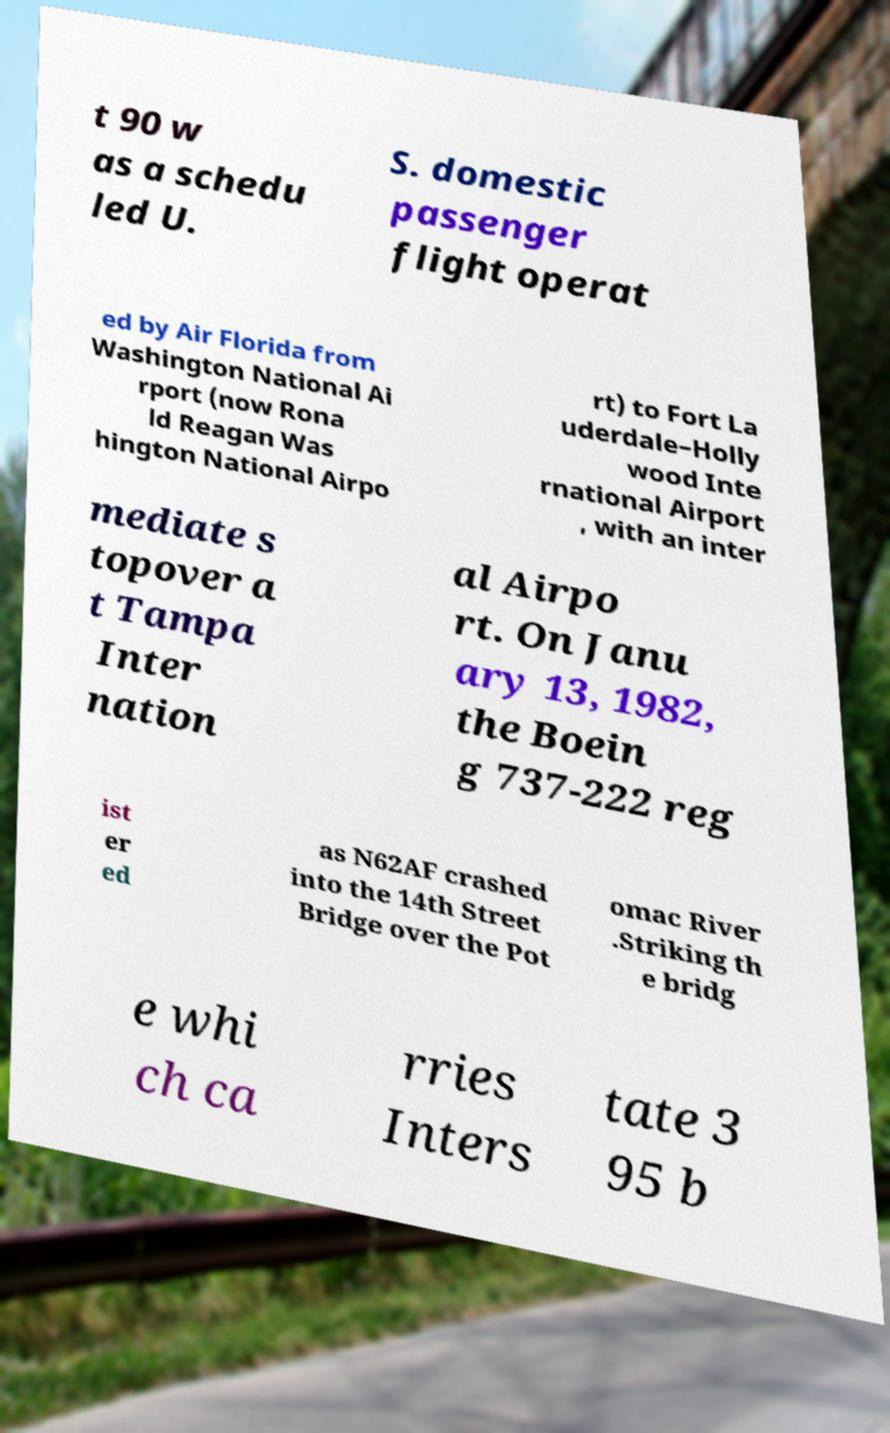Could you assist in decoding the text presented in this image and type it out clearly? t 90 w as a schedu led U. S. domestic passenger flight operat ed by Air Florida from Washington National Ai rport (now Rona ld Reagan Was hington National Airpo rt) to Fort La uderdale–Holly wood Inte rnational Airport , with an inter mediate s topover a t Tampa Inter nation al Airpo rt. On Janu ary 13, 1982, the Boein g 737-222 reg ist er ed as N62AF crashed into the 14th Street Bridge over the Pot omac River .Striking th e bridg e whi ch ca rries Inters tate 3 95 b 